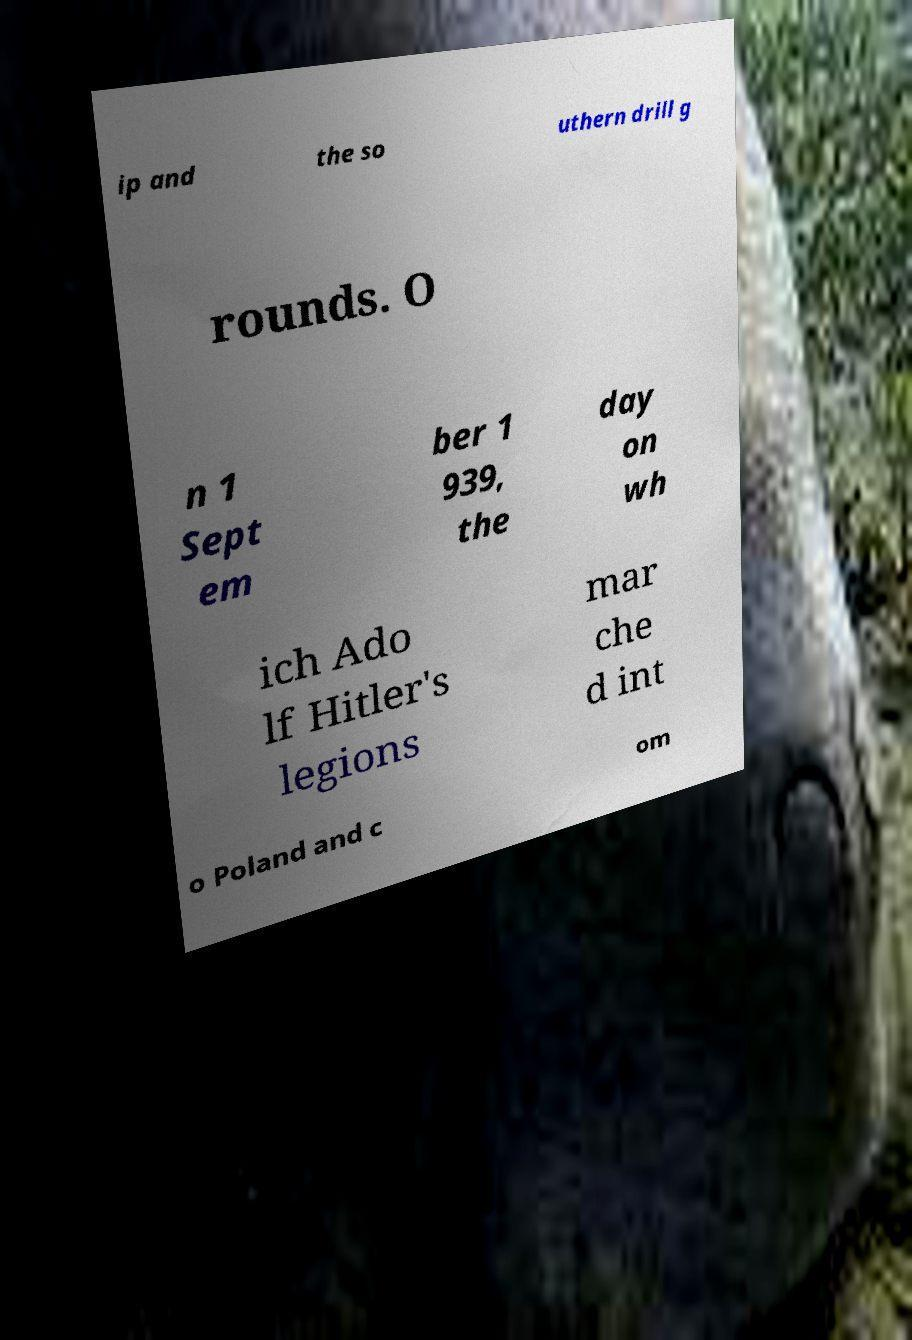There's text embedded in this image that I need extracted. Can you transcribe it verbatim? ip and the so uthern drill g rounds. O n 1 Sept em ber 1 939, the day on wh ich Ado lf Hitler's legions mar che d int o Poland and c om 